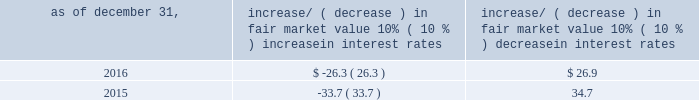Item 7a .
Quantitative and qualitative disclosures about market risk ( amounts in millions ) in the normal course of business , we are exposed to market risks related to interest rates , foreign currency rates and certain balance sheet items .
From time to time , we use derivative instruments , pursuant to established guidelines and policies , to manage some portion of these risks .
Derivative instruments utilized in our hedging activities are viewed as risk management tools and are not used for trading or speculative purposes .
Interest rates our exposure to market risk for changes in interest rates relates primarily to the fair market value and cash flows of our debt obligations .
The majority of our debt ( approximately 93% ( 93 % ) and 89% ( 89 % ) as of december 31 , 2016 and 2015 , respectively ) bears interest at fixed rates .
We do have debt with variable interest rates , but a 10% ( 10 % ) increase or decrease in interest rates would not be material to our interest expense or cash flows .
The fair market value of our debt is sensitive to changes in interest rates , and the impact of a 10% ( 10 % ) change in interest rates is summarized below .
Increase/ ( decrease ) in fair market value as of december 31 , 10% ( 10 % ) increase in interest rates 10% ( 10 % ) decrease in interest rates .
We have used interest rate swaps for risk management purposes to manage our exposure to changes in interest rates .
We do not have any interest rate swaps outstanding as of december 31 , 2016 .
We had $ 1100.6 of cash , cash equivalents and marketable securities as of december 31 , 2016 that we generally invest in conservative , short-term bank deposits or securities .
The interest income generated from these investments is subject to both domestic and foreign interest rate movements .
During 2016 and 2015 , we had interest income of $ 20.1 and $ 22.8 , respectively .
Based on our 2016 results , a 100 basis-point increase or decrease in interest rates would affect our interest income by approximately $ 11.0 , assuming that all cash , cash equivalents and marketable securities are impacted in the same manner and balances remain constant from year-end 2016 levels .
Foreign currency rates we are subject to translation and transaction risks related to changes in foreign currency exchange rates .
Since we report revenues and expenses in u.s .
Dollars , changes in exchange rates may either positively or negatively affect our consolidated revenues and expenses ( as expressed in u.s .
Dollars ) from foreign operations .
The foreign currencies that most impacted our results during 2016 included the british pound sterling and , to a lesser extent , the argentine peso , brazilian real and japanese yen .
Based on 2016 exchange rates and operating results , if the u.s .
Dollar were to strengthen or weaken by 10% ( 10 % ) , we currently estimate operating income would decrease or increase approximately 4% ( 4 % ) , assuming that all currencies are impacted in the same manner and our international revenue and expenses remain constant at 2016 levels .
The functional currency of our foreign operations is generally their respective local currency .
Assets and liabilities are translated at the exchange rates in effect at the balance sheet date , and revenues and expenses are translated at the average exchange rates during the period presented .
The resulting translation adjustments are recorded as a component of accumulated other comprehensive loss , net of tax , in the stockholders 2019 equity section of our consolidated balance sheets .
Our foreign subsidiaries generally collect revenues and pay expenses in their functional currency , mitigating transaction risk .
However , certain subsidiaries may enter into transactions in currencies other than their functional currency .
Assets and liabilities denominated in currencies other than the functional currency are susceptible to movements in foreign currency until final settlement .
Currency transaction gains or losses primarily arising from transactions in currencies other than the functional currency are included in office and general expenses .
We regularly review our foreign exchange exposures that may have a material impact on our business and from time to time use foreign currency forward exchange contracts or other derivative financial instruments to hedge the effects of potential adverse fluctuations in foreign currency exchange rates arising from these exposures .
We do not enter into foreign exchange contracts or other derivatives for speculative purposes. .
What percent cash and equivalents did the interest income generated during 2015? 
Rationale: to find the percentage increase in the interest income for 2015 , one must take the total cash and equivalents and subtract it by the interest income for 2015 , then take that solution and divide it by the cash and equivalents . then subtract 1 by the answer .
Computations: (1 - ((1100.6 - 22.8) / 1100.6))
Answer: 0.02072. 